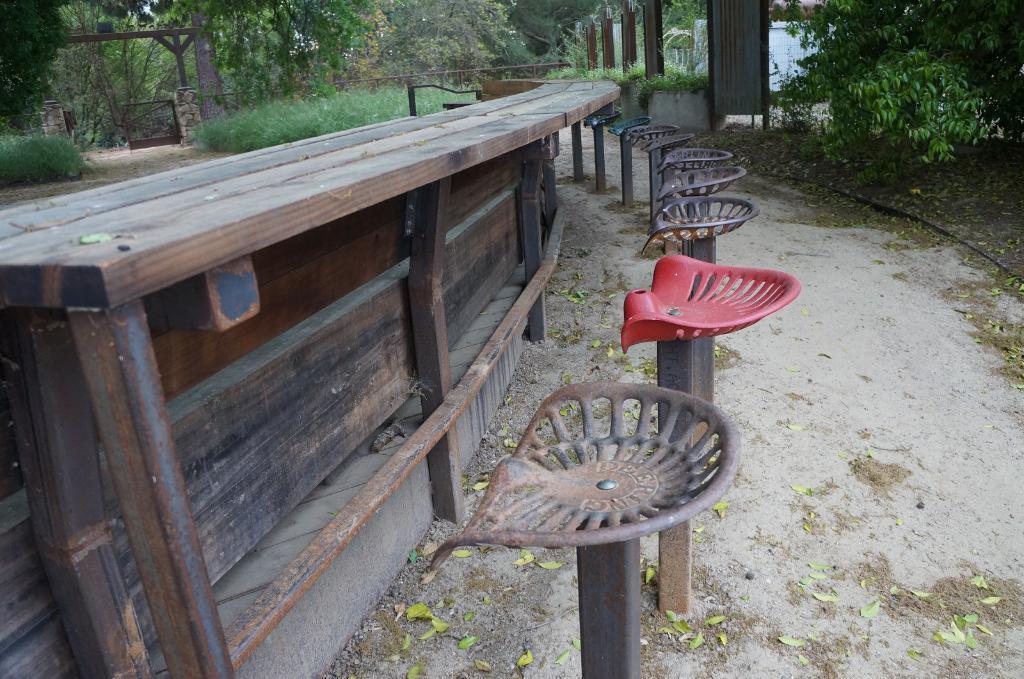Describe this image in one or two sentences. In this image, on the right side, we can see some trees and plants. In the middle of the image, we can see chairs. On the left side, we can see a table. On the left side, we can see some trees and plants. On the left side, we can also see a door. In the background, we can see a wall, pillars. At the bottom, we can see a land with some leaves and stones. 